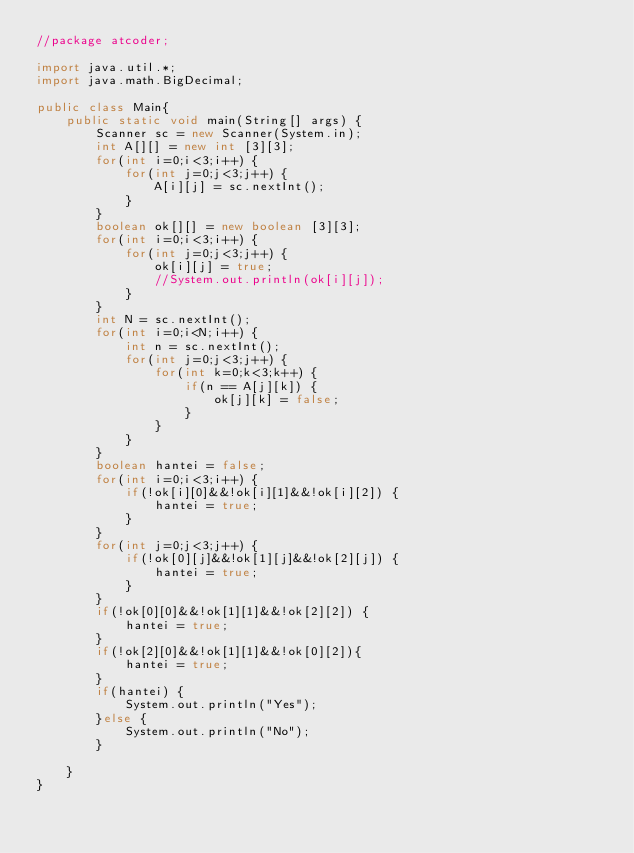<code> <loc_0><loc_0><loc_500><loc_500><_Java_>//package atcoder;
 
import java.util.*;
import java.math.BigDecimal;
 
public class Main{
	public static void main(String[] args) {
		Scanner sc = new Scanner(System.in);
		int A[][] = new int [3][3];
		for(int i=0;i<3;i++) {
			for(int j=0;j<3;j++) {
				A[i][j] = sc.nextInt();
			}
		}
		boolean ok[][] = new boolean [3][3];
		for(int i=0;i<3;i++) {
			for(int j=0;j<3;j++) {
				ok[i][j] = true;
				//System.out.println(ok[i][j]);
			}
		}
		int N = sc.nextInt();
		for(int i=0;i<N;i++) {
			int n = sc.nextInt();
			for(int j=0;j<3;j++) {
				for(int k=0;k<3;k++) {
					if(n == A[j][k]) {
						ok[j][k] = false;
					}
				}
			}
		}
		boolean hantei = false;
		for(int i=0;i<3;i++) {
			if(!ok[i][0]&&!ok[i][1]&&!ok[i][2]) {
				hantei = true;
			}
		}
		for(int j=0;j<3;j++) {
			if(!ok[0][j]&&!ok[1][j]&&!ok[2][j]) {
				hantei = true;
			}
		}
		if(!ok[0][0]&&!ok[1][1]&&!ok[2][2]) {
			hantei = true;
		}
		if(!ok[2][0]&&!ok[1][1]&&!ok[0][2]){
			hantei = true;
		}
		if(hantei) {
			System.out.println("Yes");
		}else {
			System.out.println("No");
		}
		
	}
}</code> 